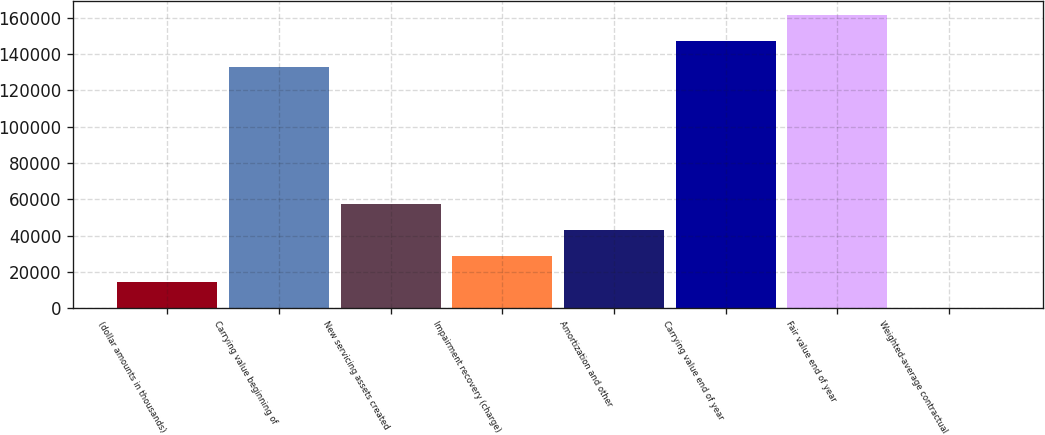<chart> <loc_0><loc_0><loc_500><loc_500><bar_chart><fcel>(dollar amounts in thousands)<fcel>Carrying value beginning of<fcel>New servicing assets created<fcel>Impairment recovery (charge)<fcel>Amortization and other<fcel>Carrying value end of year<fcel>Fair value end of year<fcel>Weighted-average contractual<nl><fcel>14348.8<fcel>132812<fcel>57377.5<fcel>28691.7<fcel>43034.6<fcel>147155<fcel>161498<fcel>5.9<nl></chart> 